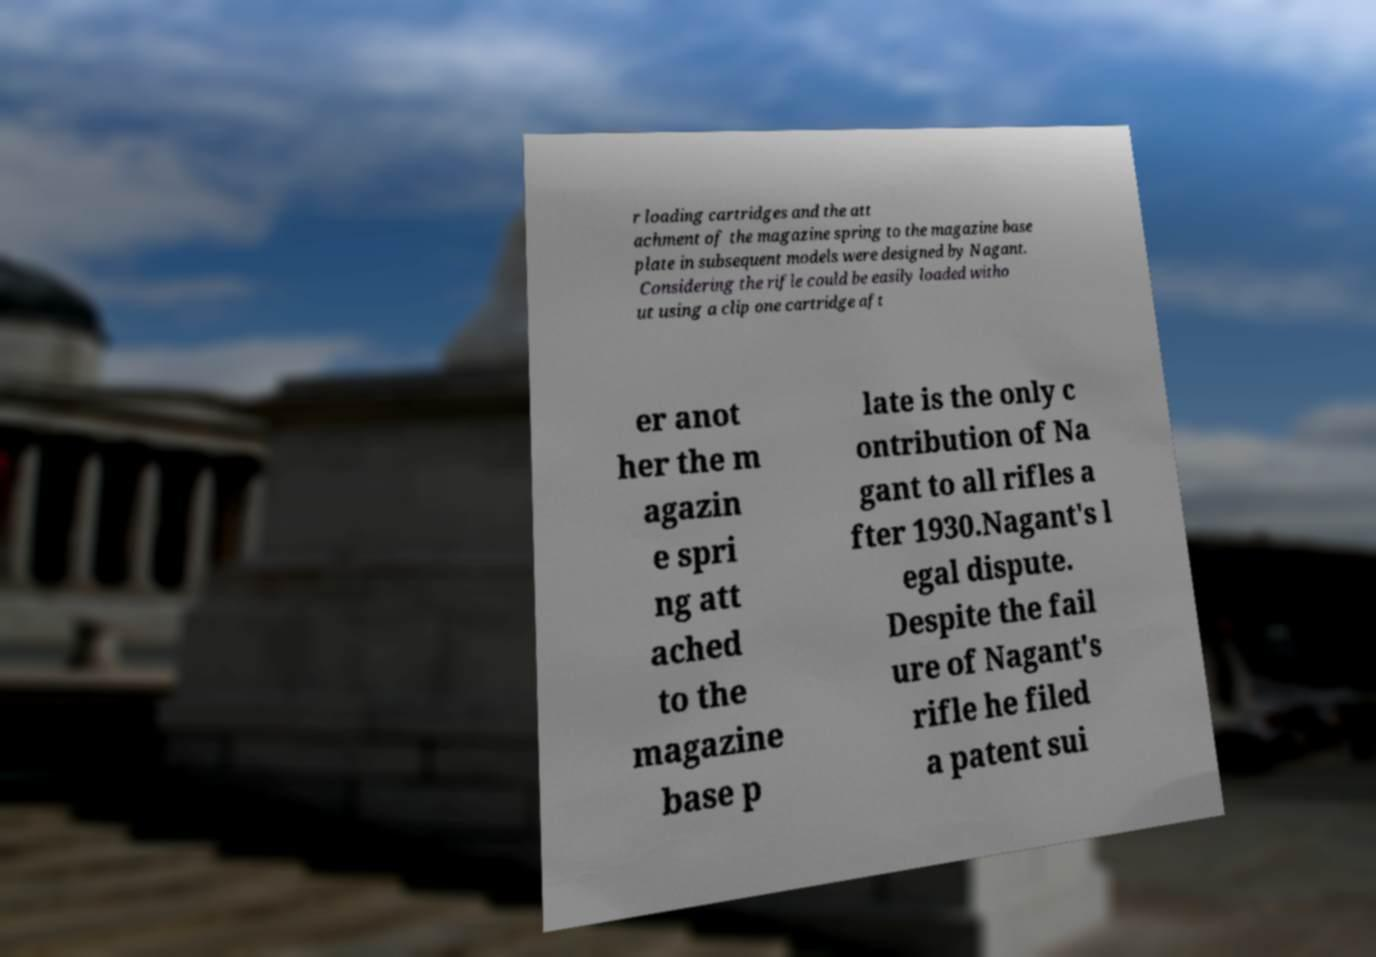Could you extract and type out the text from this image? r loading cartridges and the att achment of the magazine spring to the magazine base plate in subsequent models were designed by Nagant. Considering the rifle could be easily loaded witho ut using a clip one cartridge aft er anot her the m agazin e spri ng att ached to the magazine base p late is the only c ontribution of Na gant to all rifles a fter 1930.Nagant's l egal dispute. Despite the fail ure of Nagant's rifle he filed a patent sui 